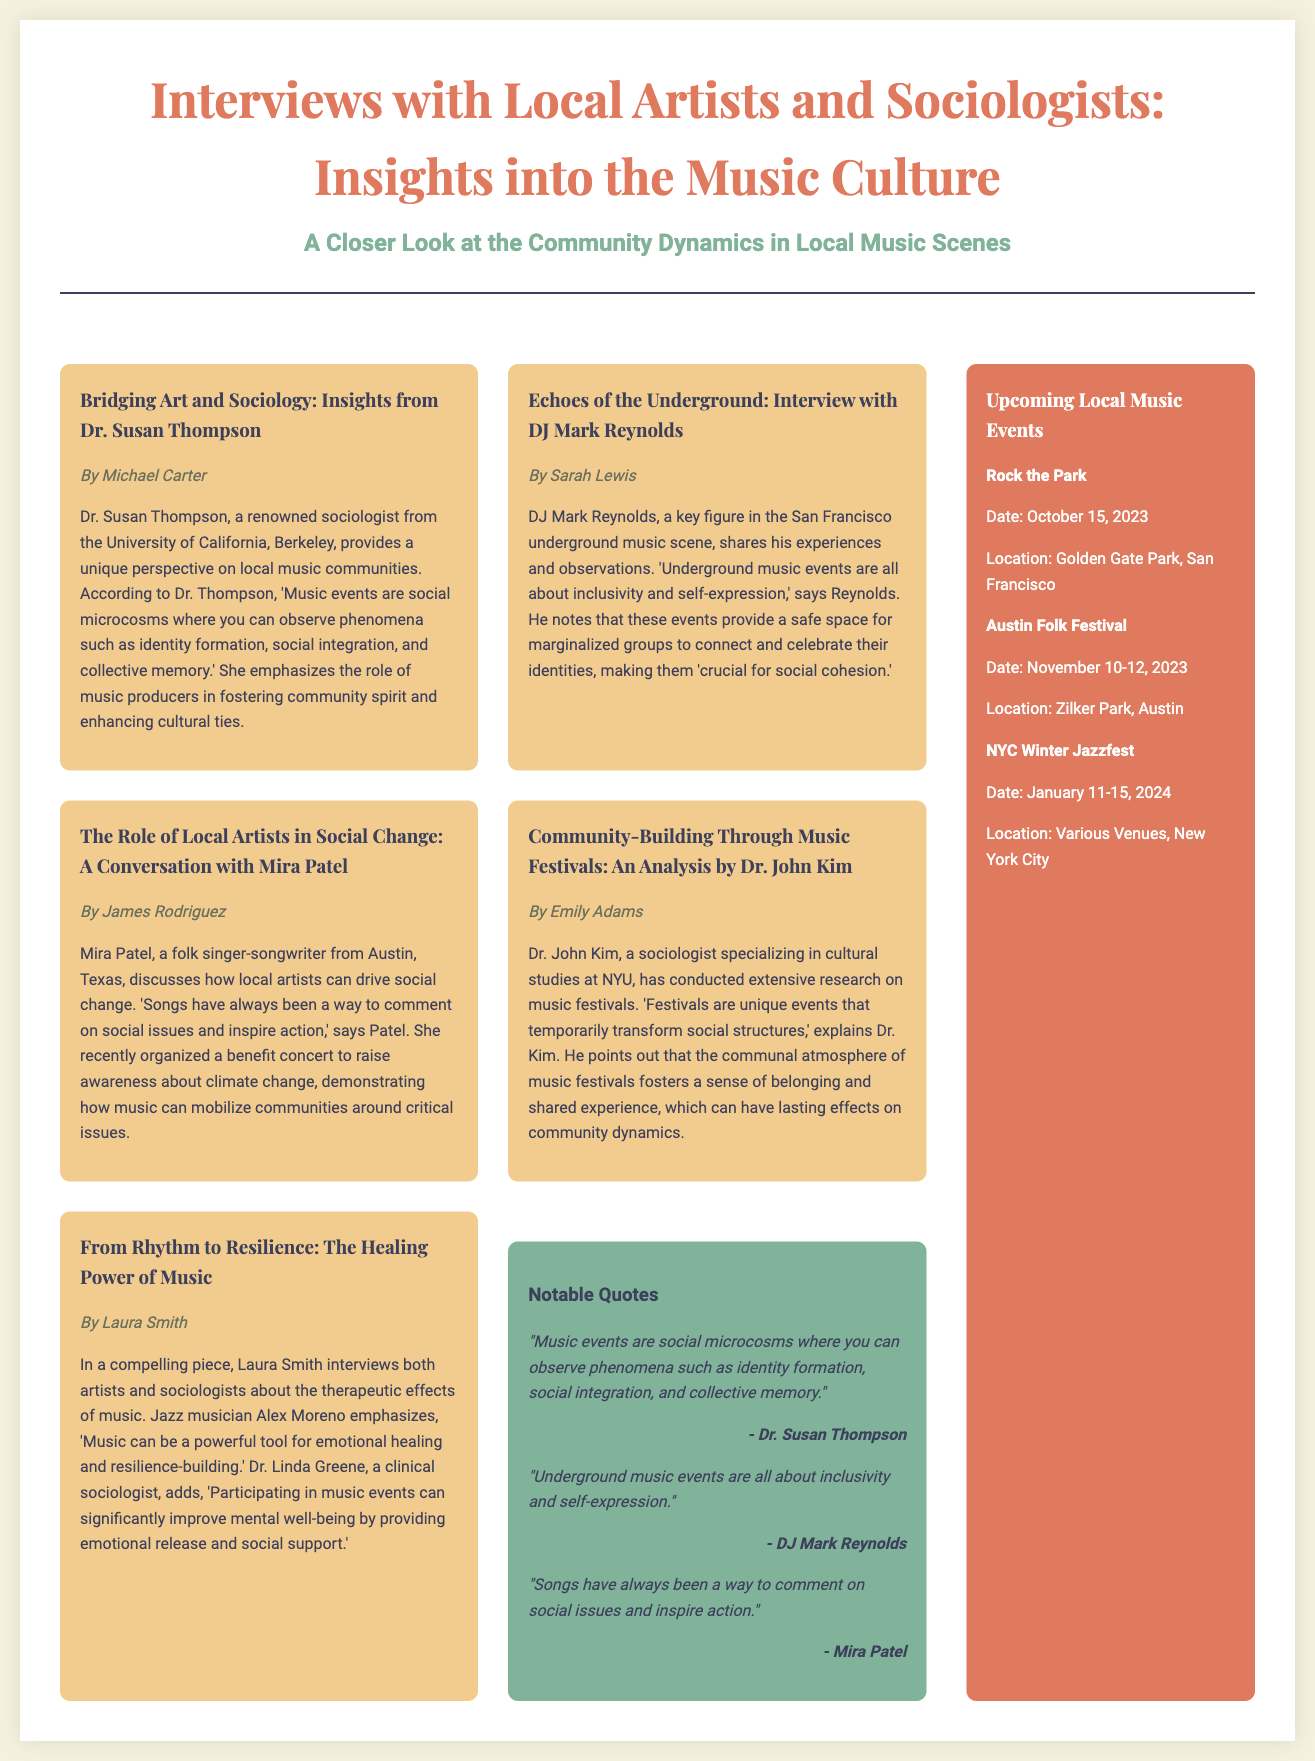what is the title of the document? The title is prominently displayed in the header section of the document.
Answer: Interviews with Local Artists and Sociologists: Insights into the Music Culture who wrote the article about Dr. Susan Thompson? The author of the article is mentioned directly below the title of the article.
Answer: Michael Carter which sociologist specializes in cultural studies? The document specifies a sociologist's area of expertise directly linked to their name.
Answer: Dr. John Kim what is the date of the Rock the Park event? The document lists upcoming local music events with corresponding dates.
Answer: October 15, 2023 what is a key theme discussed by DJ Mark Reynolds? The key themes are highlighted in quotes attributed to the interviewee in their respective articles.
Answer: Inclusivity who organized a benefit concert for climate change? The document attributes this action to a specific artist mentioned in an article.
Answer: Mira Patel what city is associated with the Austin Folk Festival? The location of each event is included with specific city names in the sidebar section.
Answer: Austin how many days does the NYC Winter Jazzfest last? The duration can be calculated based on the start and end dates provided in the document.
Answer: 5 days 